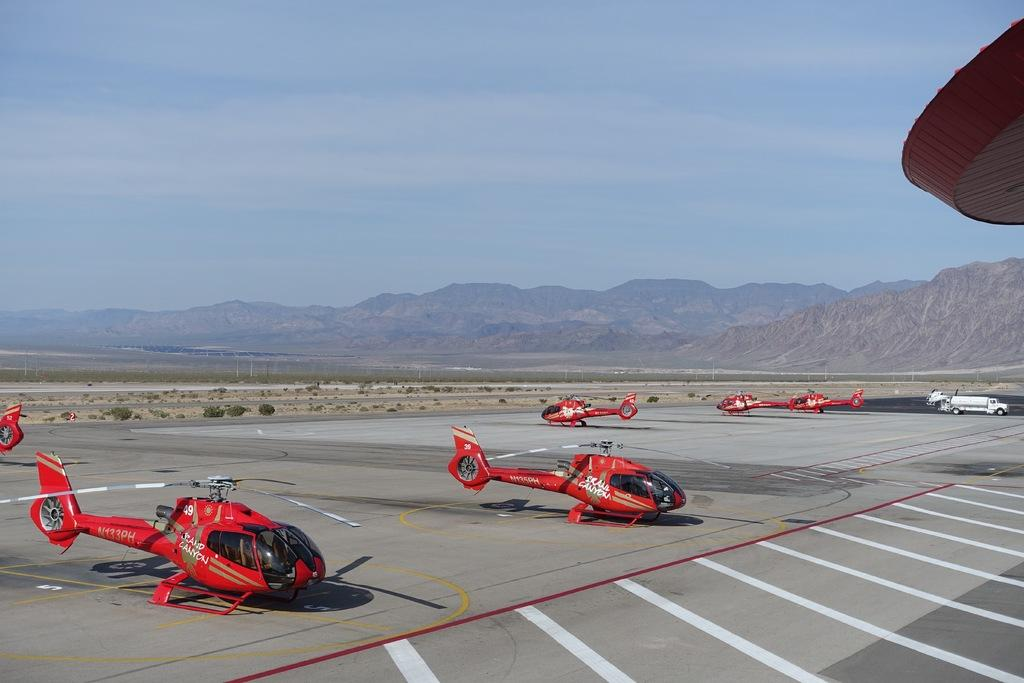What type of vehicles are in the image? There are aircrafts in the image. What color are the aircrafts? The aircrafts are red in color. What can be seen in the background of the image? There are plants and mountains in the background of the image. What color are the plants? The plants are green in color. What is the color of the sky in the image? The sky is blue in color. Is there a locket hanging from the aircraft in the image? There is no locket present in the image. Can you see a swing in the background of the image? There is no swing visible in the image; only plants, mountains, and the sky are present. 